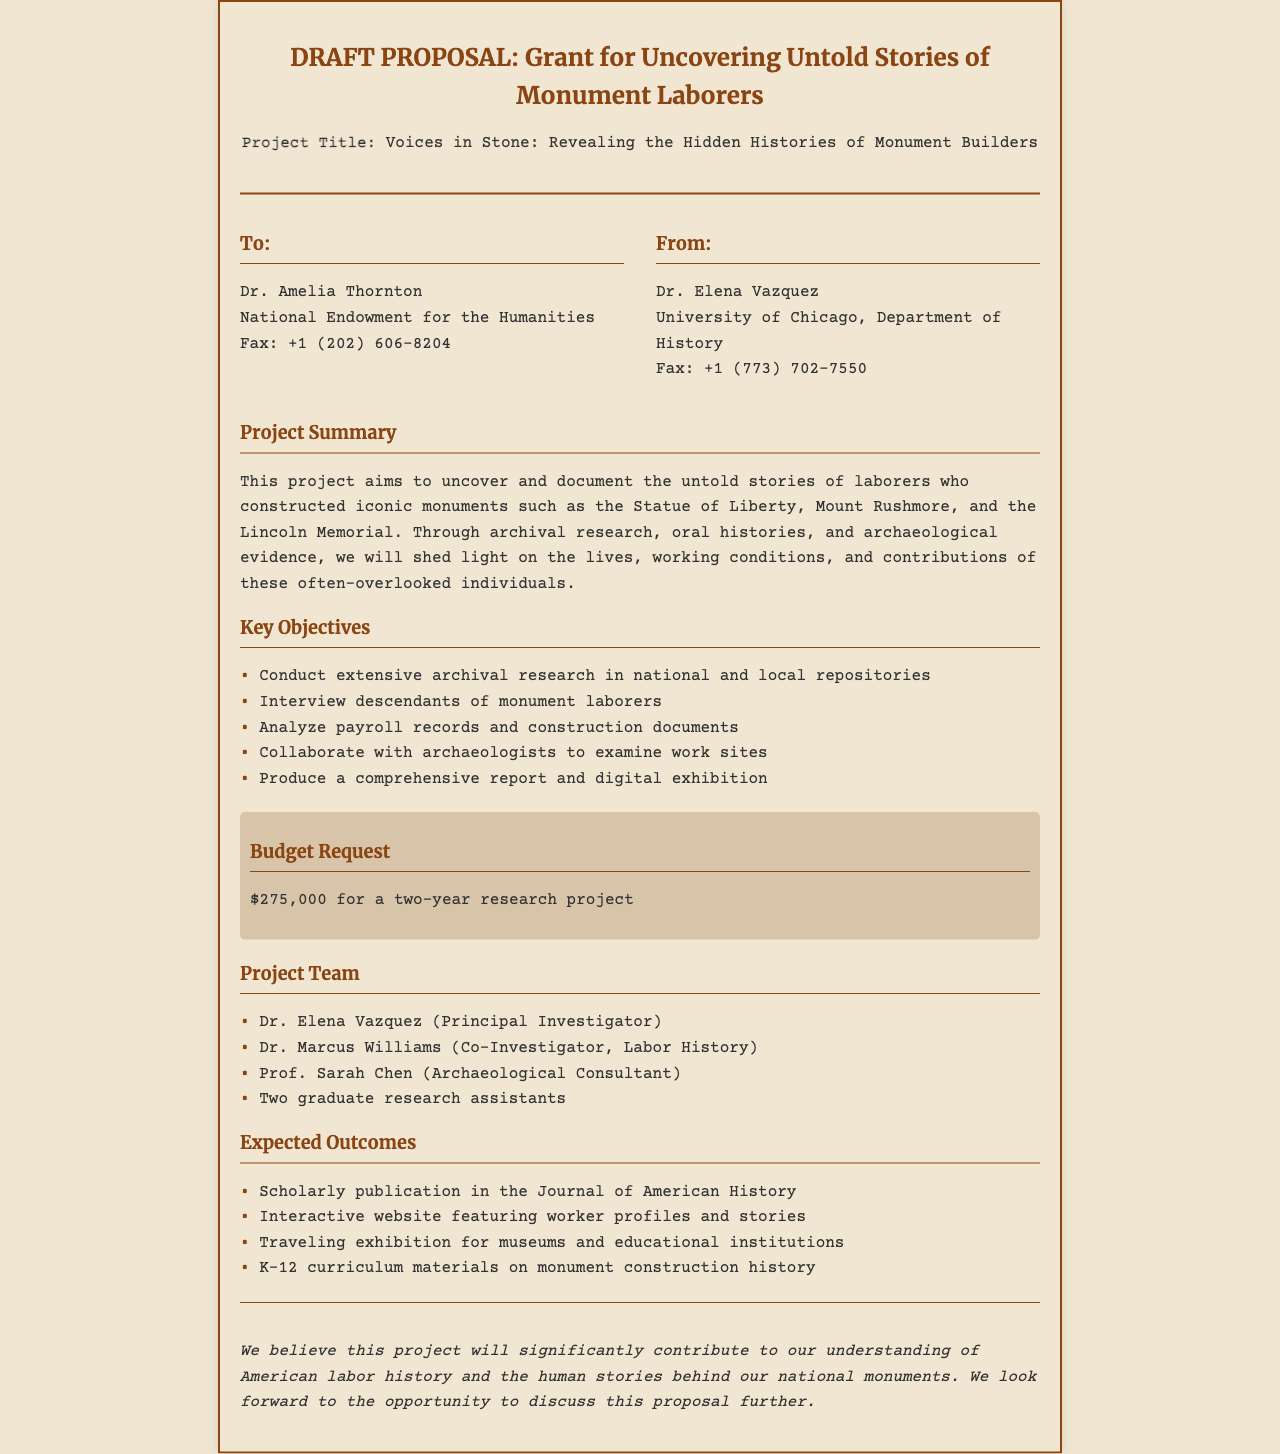What is the project title? The project title is clearly stated in the document, and it is "Voices in Stone: Revealing the Hidden Histories of Monument Builders."
Answer: Voices in Stone: Revealing the Hidden Histories of Monument Builders Who is the Principal Investigator? The document lists the project team and identifies Dr. Elena Vazquez as the Principal Investigator.
Answer: Dr. Elena Vazquez How much funding is requested for the project? The budget section specifies the total amount requested for the two-year research project, which is $275,000.
Answer: $275,000 What type of research will be conducted? The project summary describes various research methods to be used, particularly highlighting archival research.
Answer: Archival research What is one expected outcome of the project? The expected outcomes section lists various results; one example is a scholarly publication in the Journal of American History.
Answer: Scholarly publication in the Journal of American History What is the fax number for Dr. Amelia Thornton? The document includes the fax number for Dr. Amelia Thornton, allowing for easy retrieval of specific contact information.
Answer: +1 (202) 606-8204 What role does Dr. Marcus Williams serve in the project team? The document outlines the roles of each team member, with Dr. Marcus Williams serving as Co-Investigator focusing on Labor History.
Answer: Co-Investigator, Labor History How long is the proposed project duration? The budget section mentions that the funding is requested for a two-year research project, indicating the timeline for completion.
Answer: Two years 